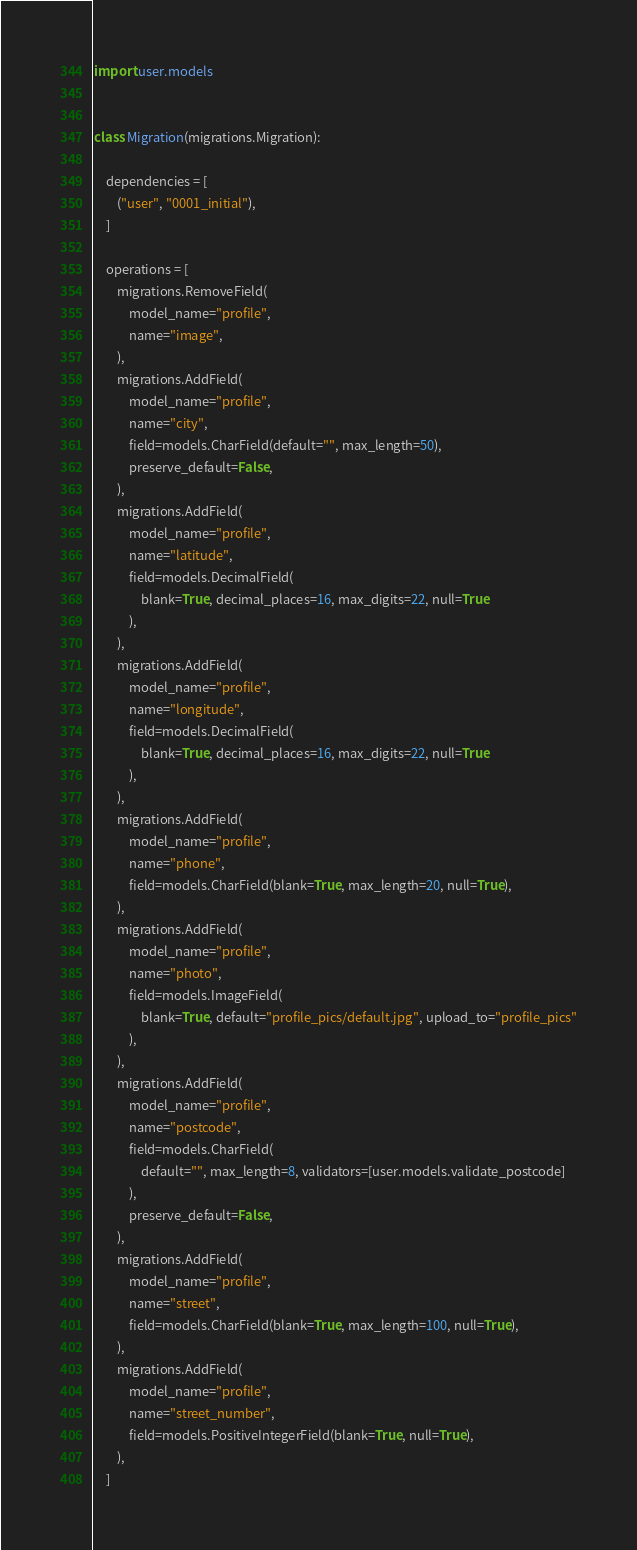<code> <loc_0><loc_0><loc_500><loc_500><_Python_>import user.models


class Migration(migrations.Migration):

    dependencies = [
        ("user", "0001_initial"),
    ]

    operations = [
        migrations.RemoveField(
            model_name="profile",
            name="image",
        ),
        migrations.AddField(
            model_name="profile",
            name="city",
            field=models.CharField(default="", max_length=50),
            preserve_default=False,
        ),
        migrations.AddField(
            model_name="profile",
            name="latitude",
            field=models.DecimalField(
                blank=True, decimal_places=16, max_digits=22, null=True
            ),
        ),
        migrations.AddField(
            model_name="profile",
            name="longitude",
            field=models.DecimalField(
                blank=True, decimal_places=16, max_digits=22, null=True
            ),
        ),
        migrations.AddField(
            model_name="profile",
            name="phone",
            field=models.CharField(blank=True, max_length=20, null=True),
        ),
        migrations.AddField(
            model_name="profile",
            name="photo",
            field=models.ImageField(
                blank=True, default="profile_pics/default.jpg", upload_to="profile_pics"
            ),
        ),
        migrations.AddField(
            model_name="profile",
            name="postcode",
            field=models.CharField(
                default="", max_length=8, validators=[user.models.validate_postcode]
            ),
            preserve_default=False,
        ),
        migrations.AddField(
            model_name="profile",
            name="street",
            field=models.CharField(blank=True, max_length=100, null=True),
        ),
        migrations.AddField(
            model_name="profile",
            name="street_number",
            field=models.PositiveIntegerField(blank=True, null=True),
        ),
    ]
</code> 